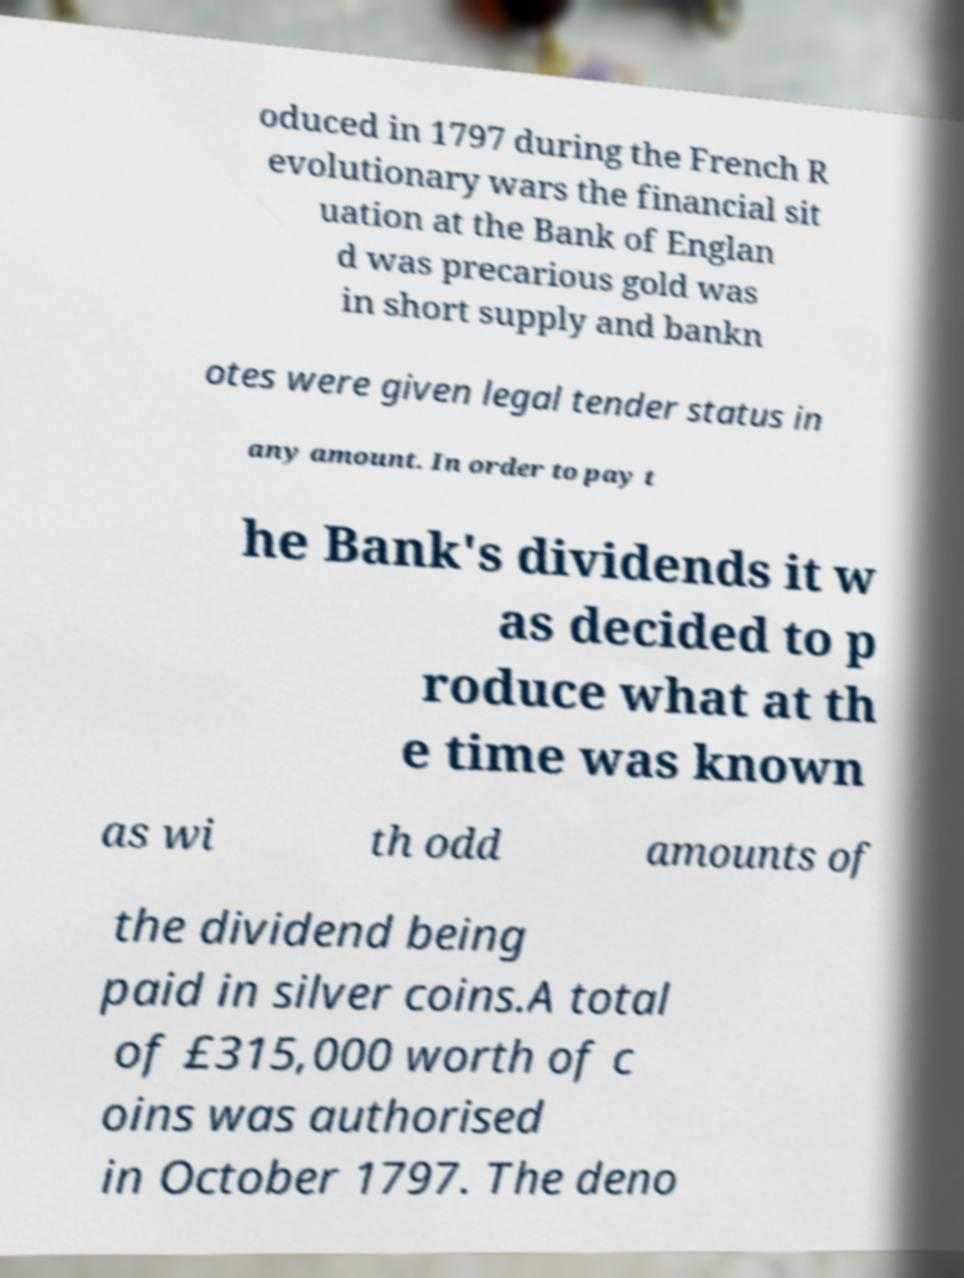I need the written content from this picture converted into text. Can you do that? oduced in 1797 during the French R evolutionary wars the financial sit uation at the Bank of Englan d was precarious gold was in short supply and bankn otes were given legal tender status in any amount. In order to pay t he Bank's dividends it w as decided to p roduce what at th e time was known as wi th odd amounts of the dividend being paid in silver coins.A total of £315,000 worth of c oins was authorised in October 1797. The deno 